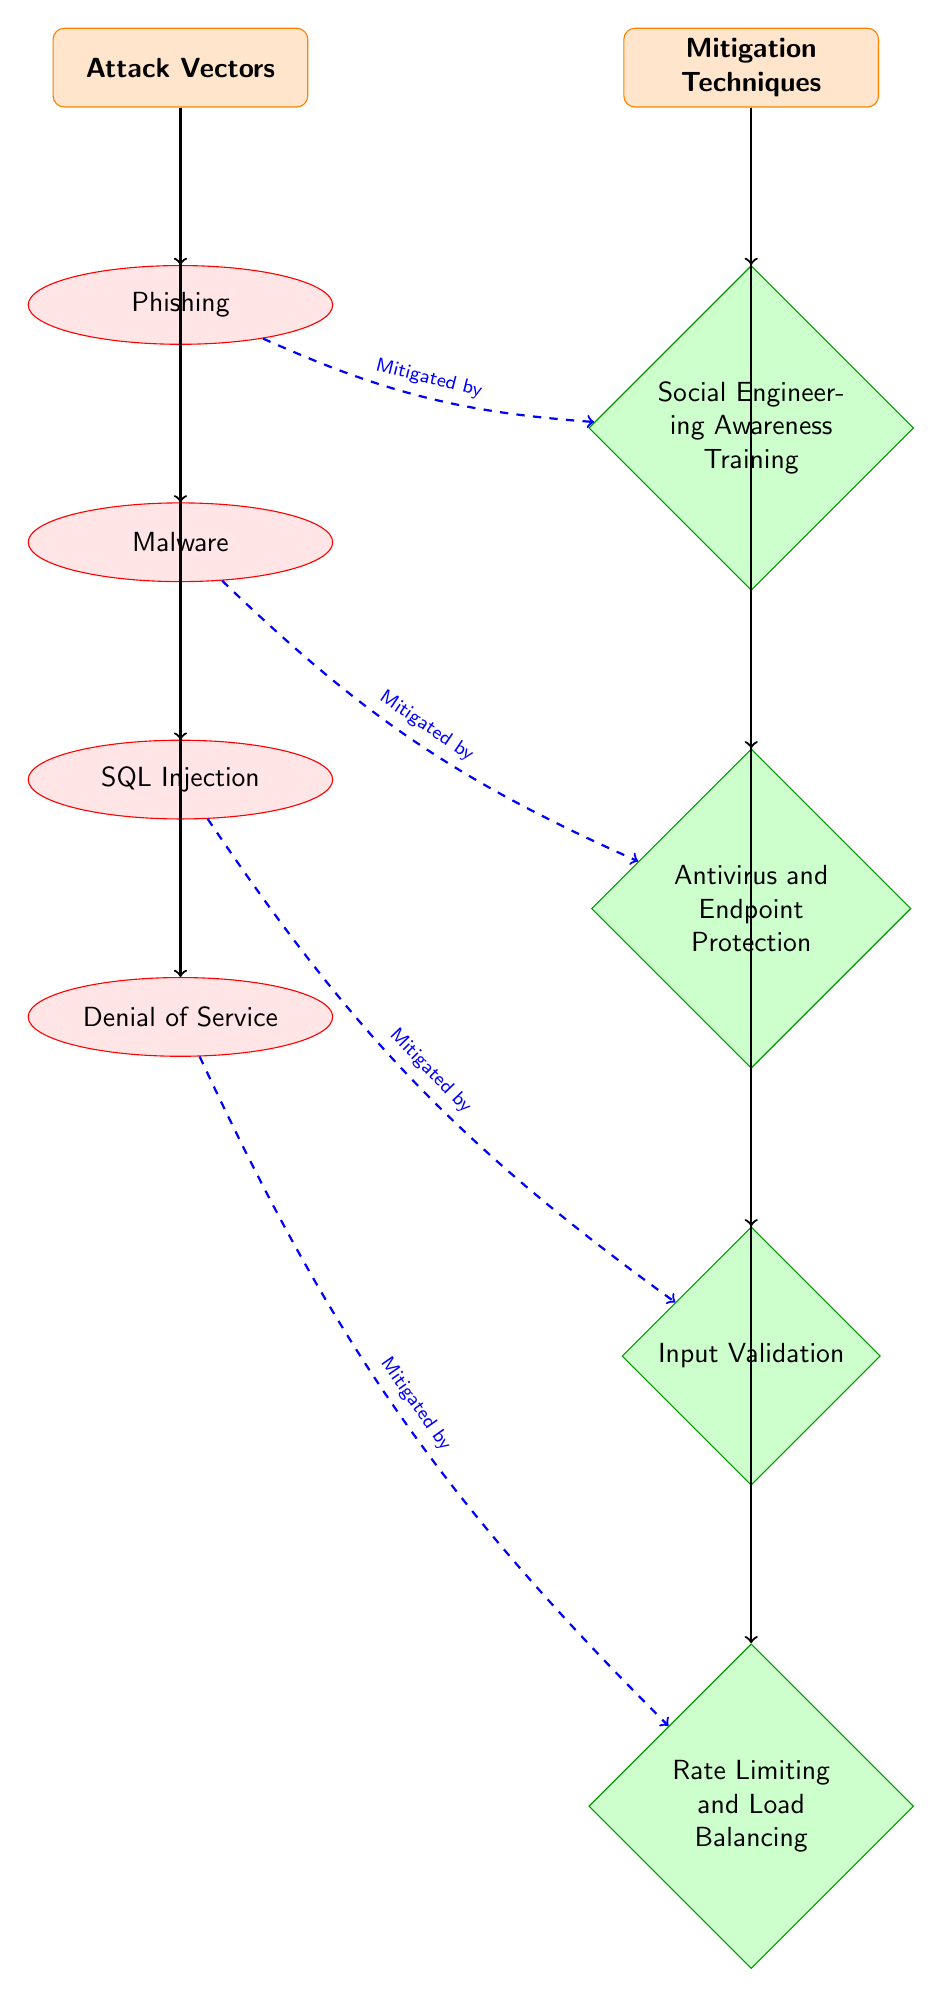What are the attack vectors shown in the diagram? The diagram lists Phishing, Malware, SQL Injection, and Denial of Service as the attack vectors under the "Attack Vectors" category.
Answer: Phishing, Malware, SQL Injection, Denial of Service How many defensive techniques are depicted in the diagram? The diagram includes four defensive techniques: Social Engineering Awareness Training, Antivirus and Endpoint Protection, Input Validation, and Rate Limiting and Load Balancing, totaling four techniques.
Answer: 4 Which attack vector is mitigated by awareness training? The diagram has a connection from Phishing to Social Engineering Awareness Training, indicating that Phishing is mitigated by awareness training.
Answer: Phishing What type of shape represents mitigation techniques in the diagram? Mitigation techniques are represented by diamond shapes in the diagram, marked with a specific style for clarity.
Answer: Diamond Is there a direct connection between SQL Injection and antivirus protection? The diagram shows an arrow linking SQL Injection to Input Validation, but there is no direct connection to Antivirus and Endpoint Protection, confirming that they are not directly related in this context.
Answer: No Which mitigation technique is associated with Denial of Service attacks? The diagram indicates that Rate Limiting and Load Balancing are associated as mitigation techniques specifically aimed at addressing Denial of Service attacks, as per the indicated paths.
Answer: Rate Limiting and Load Balancing How many unique attack vectors are listed? There are four unique attack vectors shown in the diagram: Phishing, Malware, SQL Injection, and Denial of Service. This is derived from counting the listed attack paths in the respective category.
Answer: 4 What is the relationship between Malware and Endpoint Protection? The diagram illustrates a mitigation connection from Malware to Antivirus and Endpoint Protection, indicating that this specific defense technique helps mitigate malware attacks.
Answer: Mitigated by Antivirus and Endpoint Protection 